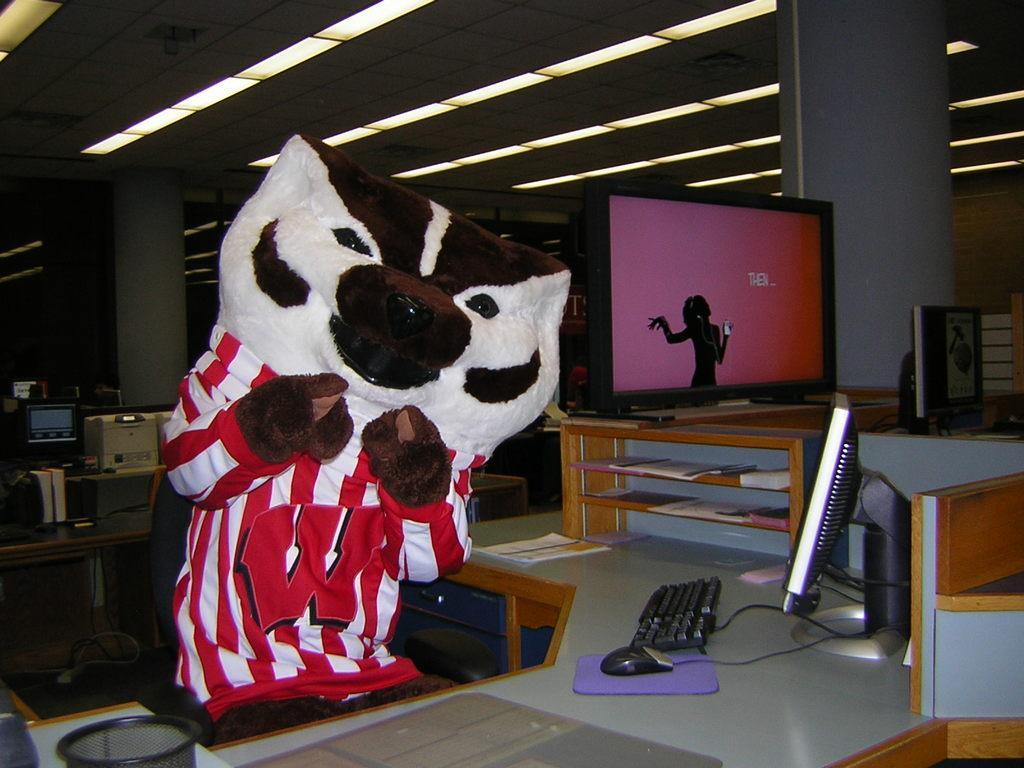In one or two sentences, can you explain what this image depicts? In the image there is a teddy bear in front of table,There is a desktop, monitor along with some books on the table. and over the ceiling there are many lights. In the background it seems to be a office. 